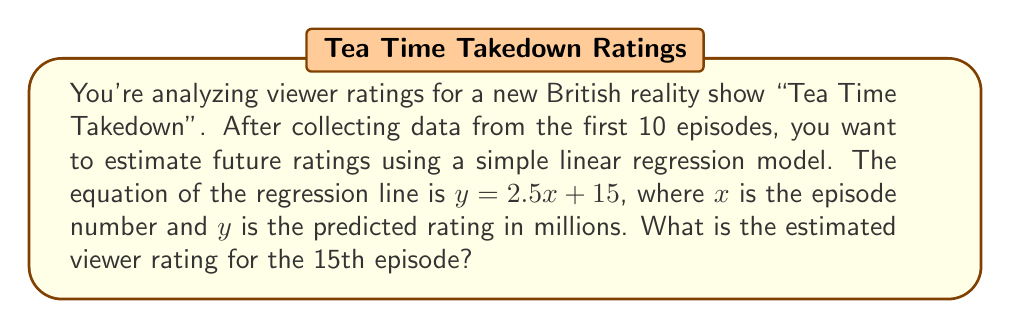Give your solution to this math problem. To solve this problem, we'll use the given linear regression model and follow these steps:

1. Identify the equation: $y = 2.5x + 15$
   Where:
   $y$ = predicted viewer rating in millions
   $x$ = episode number
   $2.5$ = slope (increase in ratings per episode)
   $15$ = y-intercept (initial rating)

2. We want to find the rating for the 15th episode, so $x = 15$

3. Substitute $x = 15$ into the equation:
   $$y = 2.5(15) + 15$$

4. Solve the equation:
   $$y = 37.5 + 15$$
   $$y = 52.5$$

Therefore, the estimated viewer rating for the 15th episode of "Tea Time Takedown" is 52.5 million viewers.
Answer: 52.5 million viewers 